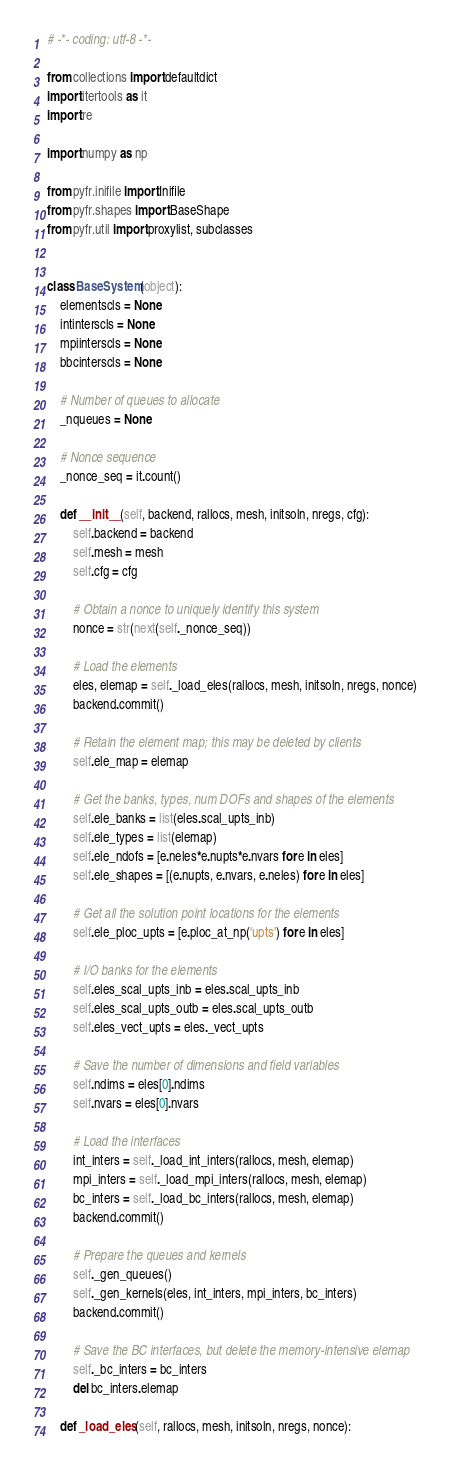<code> <loc_0><loc_0><loc_500><loc_500><_Python_># -*- coding: utf-8 -*-

from collections import defaultdict
import itertools as it
import re

import numpy as np

from pyfr.inifile import Inifile
from pyfr.shapes import BaseShape
from pyfr.util import proxylist, subclasses


class BaseSystem(object):
    elementscls = None
    intinterscls = None
    mpiinterscls = None
    bbcinterscls = None

    # Number of queues to allocate
    _nqueues = None

    # Nonce sequence
    _nonce_seq = it.count()

    def __init__(self, backend, rallocs, mesh, initsoln, nregs, cfg):
        self.backend = backend
        self.mesh = mesh
        self.cfg = cfg

        # Obtain a nonce to uniquely identify this system
        nonce = str(next(self._nonce_seq))

        # Load the elements
        eles, elemap = self._load_eles(rallocs, mesh, initsoln, nregs, nonce)
        backend.commit()

        # Retain the element map; this may be deleted by clients
        self.ele_map = elemap

        # Get the banks, types, num DOFs and shapes of the elements
        self.ele_banks = list(eles.scal_upts_inb)
        self.ele_types = list(elemap)
        self.ele_ndofs = [e.neles*e.nupts*e.nvars for e in eles]
        self.ele_shapes = [(e.nupts, e.nvars, e.neles) for e in eles]

        # Get all the solution point locations for the elements
        self.ele_ploc_upts = [e.ploc_at_np('upts') for e in eles]

        # I/O banks for the elements
        self.eles_scal_upts_inb = eles.scal_upts_inb
        self.eles_scal_upts_outb = eles.scal_upts_outb
        self.eles_vect_upts = eles._vect_upts

        # Save the number of dimensions and field variables
        self.ndims = eles[0].ndims
        self.nvars = eles[0].nvars

        # Load the interfaces
        int_inters = self._load_int_inters(rallocs, mesh, elemap)
        mpi_inters = self._load_mpi_inters(rallocs, mesh, elemap)
        bc_inters = self._load_bc_inters(rallocs, mesh, elemap)
        backend.commit()

        # Prepare the queues and kernels
        self._gen_queues()
        self._gen_kernels(eles, int_inters, mpi_inters, bc_inters)
        backend.commit()

        # Save the BC interfaces, but delete the memory-intensive elemap
        self._bc_inters = bc_inters
        del bc_inters.elemap

    def _load_eles(self, rallocs, mesh, initsoln, nregs, nonce):</code> 